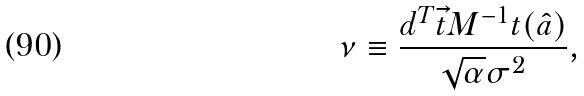<formula> <loc_0><loc_0><loc_500><loc_500>\nu \equiv \frac { d ^ { T } \vec { t } { M } ^ { - 1 } t ( \hat { a } ) } { \sqrt { \alpha } \sigma ^ { 2 } } ,</formula> 